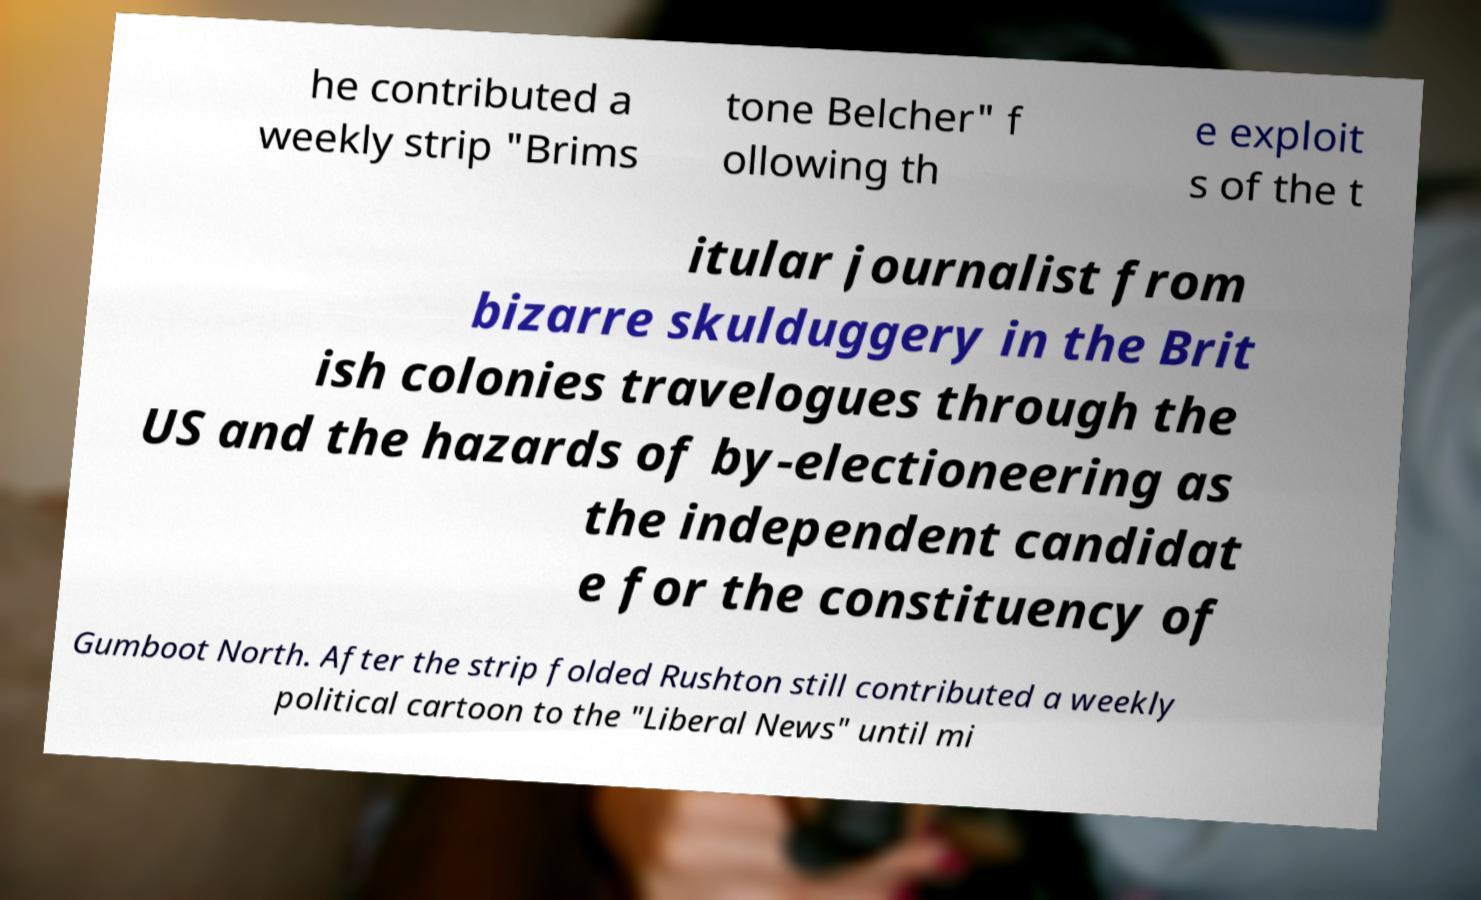Please identify and transcribe the text found in this image. he contributed a weekly strip "Brims tone Belcher" f ollowing th e exploit s of the t itular journalist from bizarre skulduggery in the Brit ish colonies travelogues through the US and the hazards of by-electioneering as the independent candidat e for the constituency of Gumboot North. After the strip folded Rushton still contributed a weekly political cartoon to the "Liberal News" until mi 